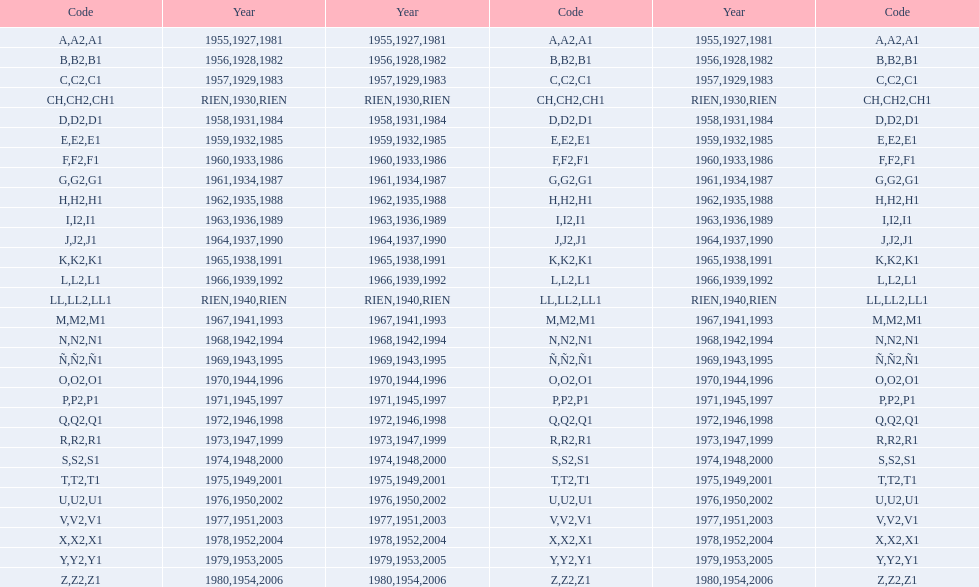Is the e code less than 1950? Yes. 